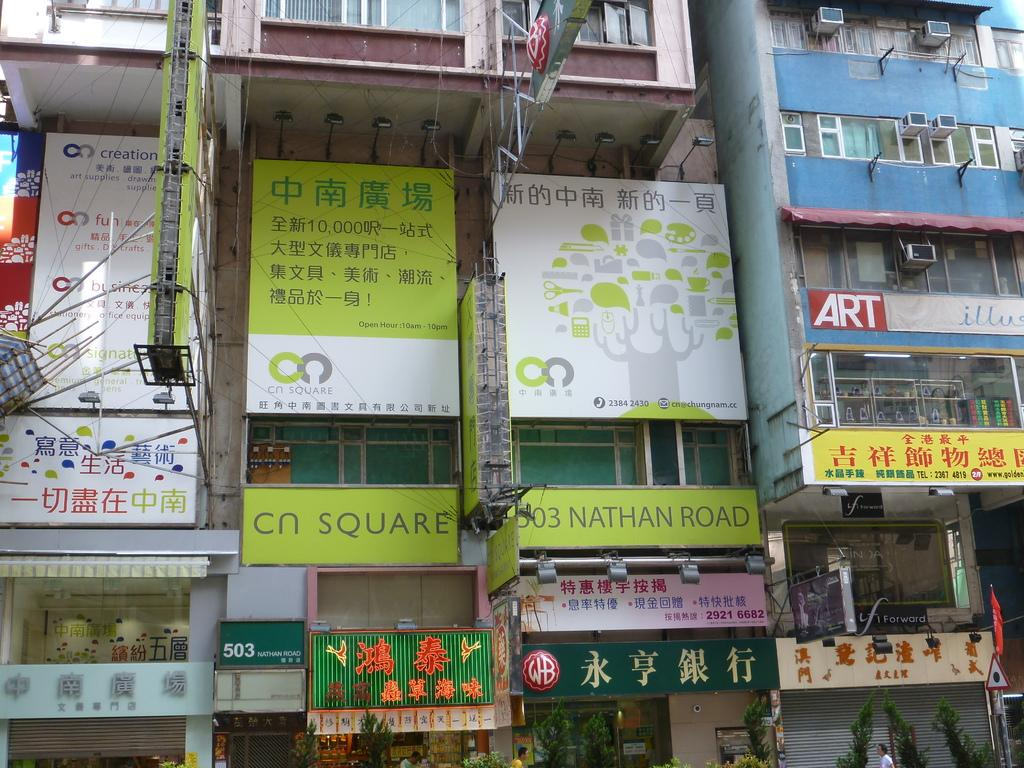What type of items can be seen on the walls in the image? There are posters and name boards in the image. What architectural feature is present in the image? There are shutters in the image. What type of vegetation is visible in the image? There are trees in the image. Who or what is present in the image? There are people in the image. What type of signage is visible in the image? There is a signboard in the image. What type of buildings are shown in the image? There are buildings with windows in the image. Are there any unidentified objects in the image? Yes, there are unspecified objects in the image. Can you see a calculator being used in the image? No, there is no calculator present in the image. 